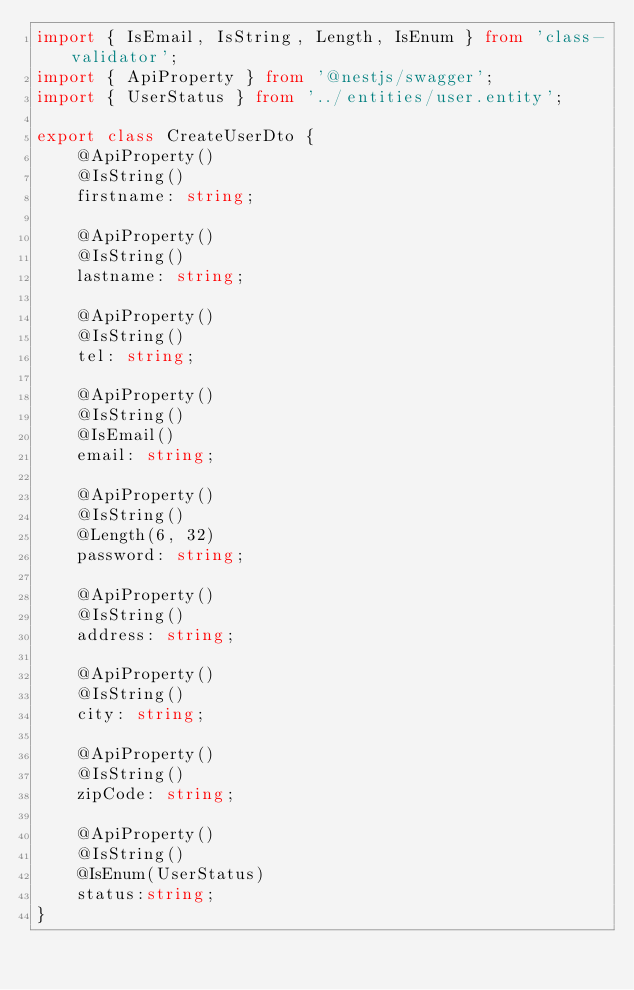<code> <loc_0><loc_0><loc_500><loc_500><_TypeScript_>import { IsEmail, IsString, Length, IsEnum } from 'class-validator';
import { ApiProperty } from '@nestjs/swagger';
import { UserStatus } from '../entities/user.entity';

export class CreateUserDto {
    @ApiProperty()
    @IsString()
    firstname: string;

    @ApiProperty()
    @IsString()
    lastname: string;

    @ApiProperty()
    @IsString()
    tel: string;

    @ApiProperty()
    @IsString()
    @IsEmail()
    email: string;

    @ApiProperty()
    @IsString()
    @Length(6, 32)
    password: string;

    @ApiProperty()
    @IsString()
    address: string;

    @ApiProperty()
    @IsString()
    city: string;

    @ApiProperty()
    @IsString()
    zipCode: string;

    @ApiProperty()
    @IsString()
    @IsEnum(UserStatus)
    status:string;
}
</code> 